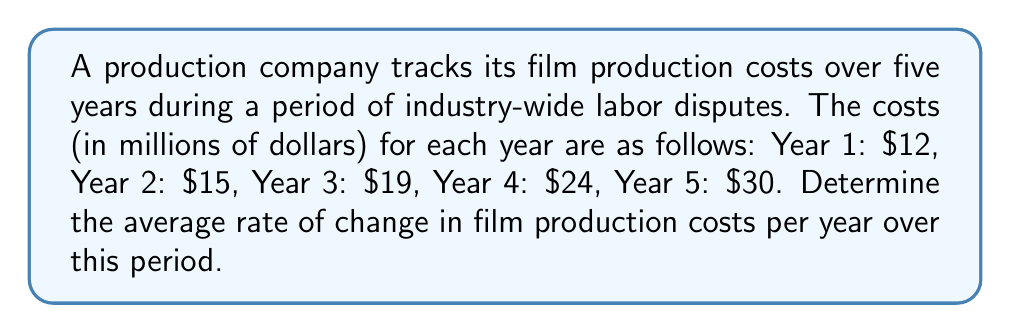Provide a solution to this math problem. To find the average rate of change in film production costs per year, we need to:

1. Calculate the total change in cost from Year 1 to Year 5:
   $\text{Total change} = \text{Final value} - \text{Initial value}$
   $\text{Total change} = $30 \text{ million} - $12 \text{ million} = $18 \text{ million}$

2. Determine the time period:
   $\text{Time period} = 5 \text{ years} - 1 \text{ year} = 4 \text{ years}$

3. Calculate the average rate of change:
   $$\text{Average rate of change} = \frac{\text{Total change}}{\text{Time period}}$$
   $$\text{Average rate of change} = \frac{$18 \text{ million}}{4 \text{ years}} = $4.5 \text{ million per year}$$

Therefore, the average rate of change in film production costs is $4.5 million per year over the five-year period.
Answer: $4.5 million per year 